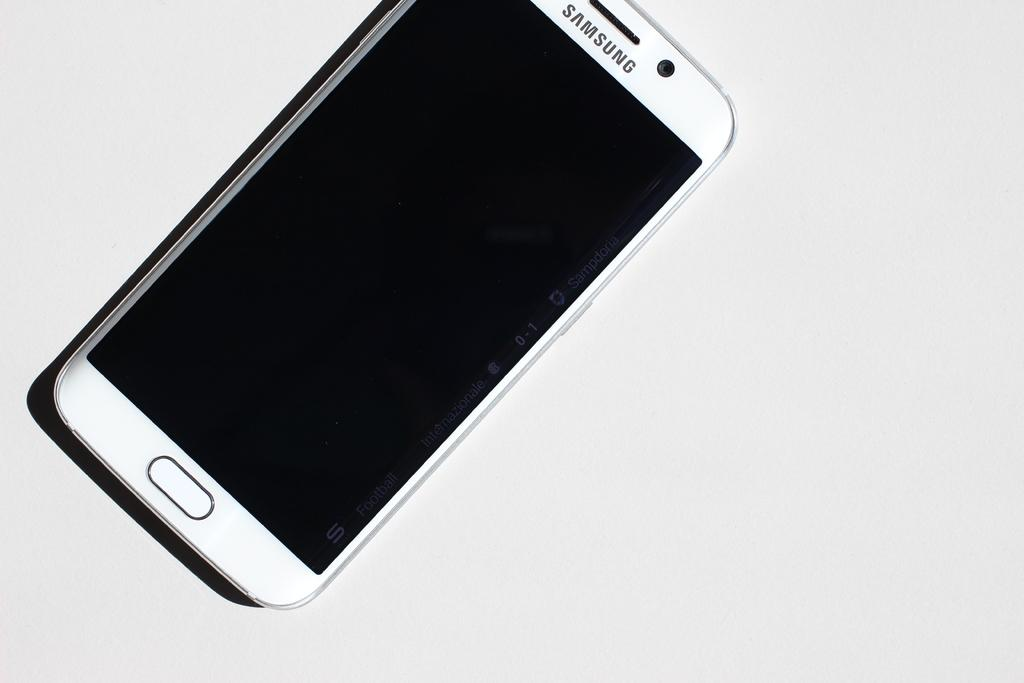<image>
Present a compact description of the photo's key features. A white Samsung phone, with a black screen is tilted on an angle for better advertisement. 